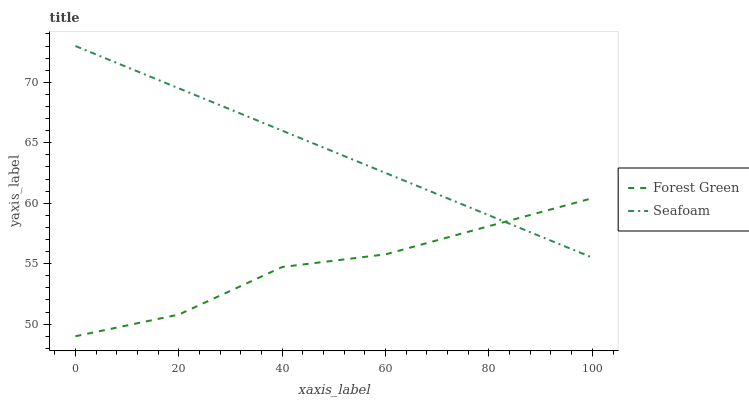Does Forest Green have the minimum area under the curve?
Answer yes or no. Yes. Does Seafoam have the maximum area under the curve?
Answer yes or no. Yes. Does Seafoam have the minimum area under the curve?
Answer yes or no. No. Is Seafoam the smoothest?
Answer yes or no. Yes. Is Forest Green the roughest?
Answer yes or no. Yes. Is Seafoam the roughest?
Answer yes or no. No. Does Seafoam have the lowest value?
Answer yes or no. No. 